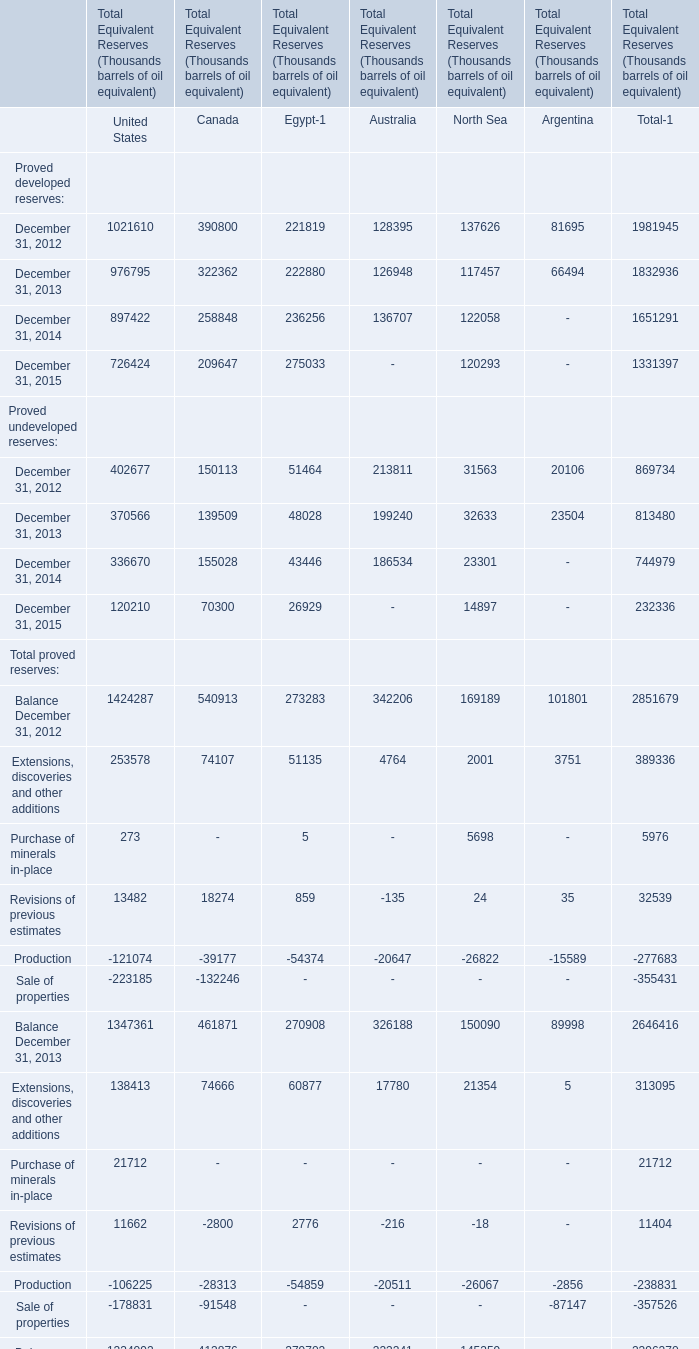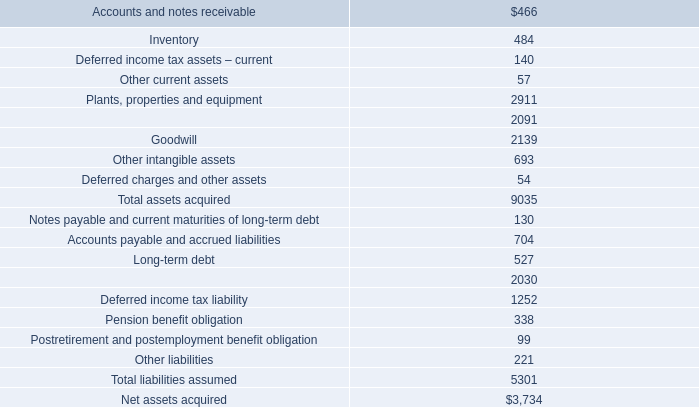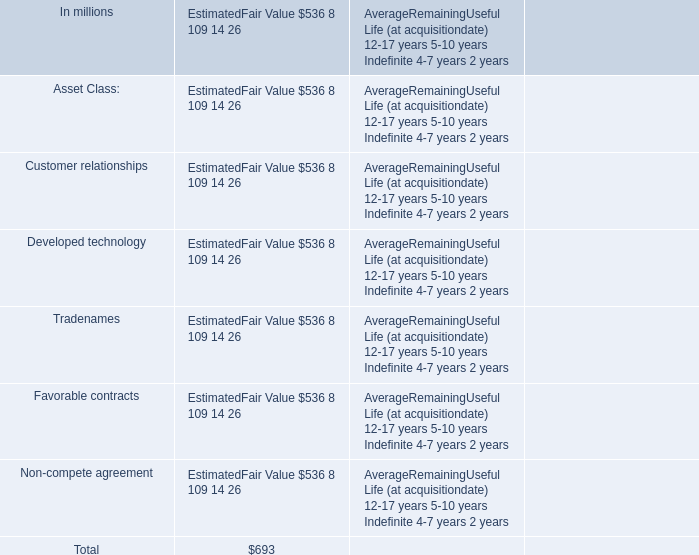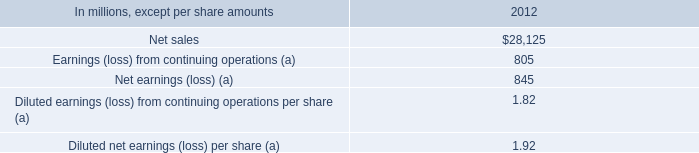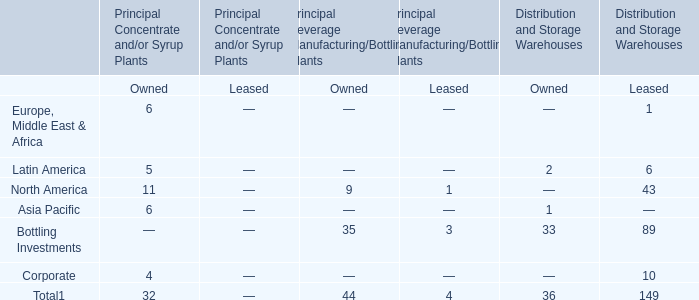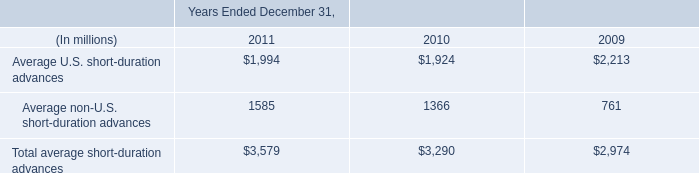What's the growth rate of Proved developed reserves in 2013? 
Computations: ((1832936 - 1981945) / 1981945)
Answer: -0.07518. 